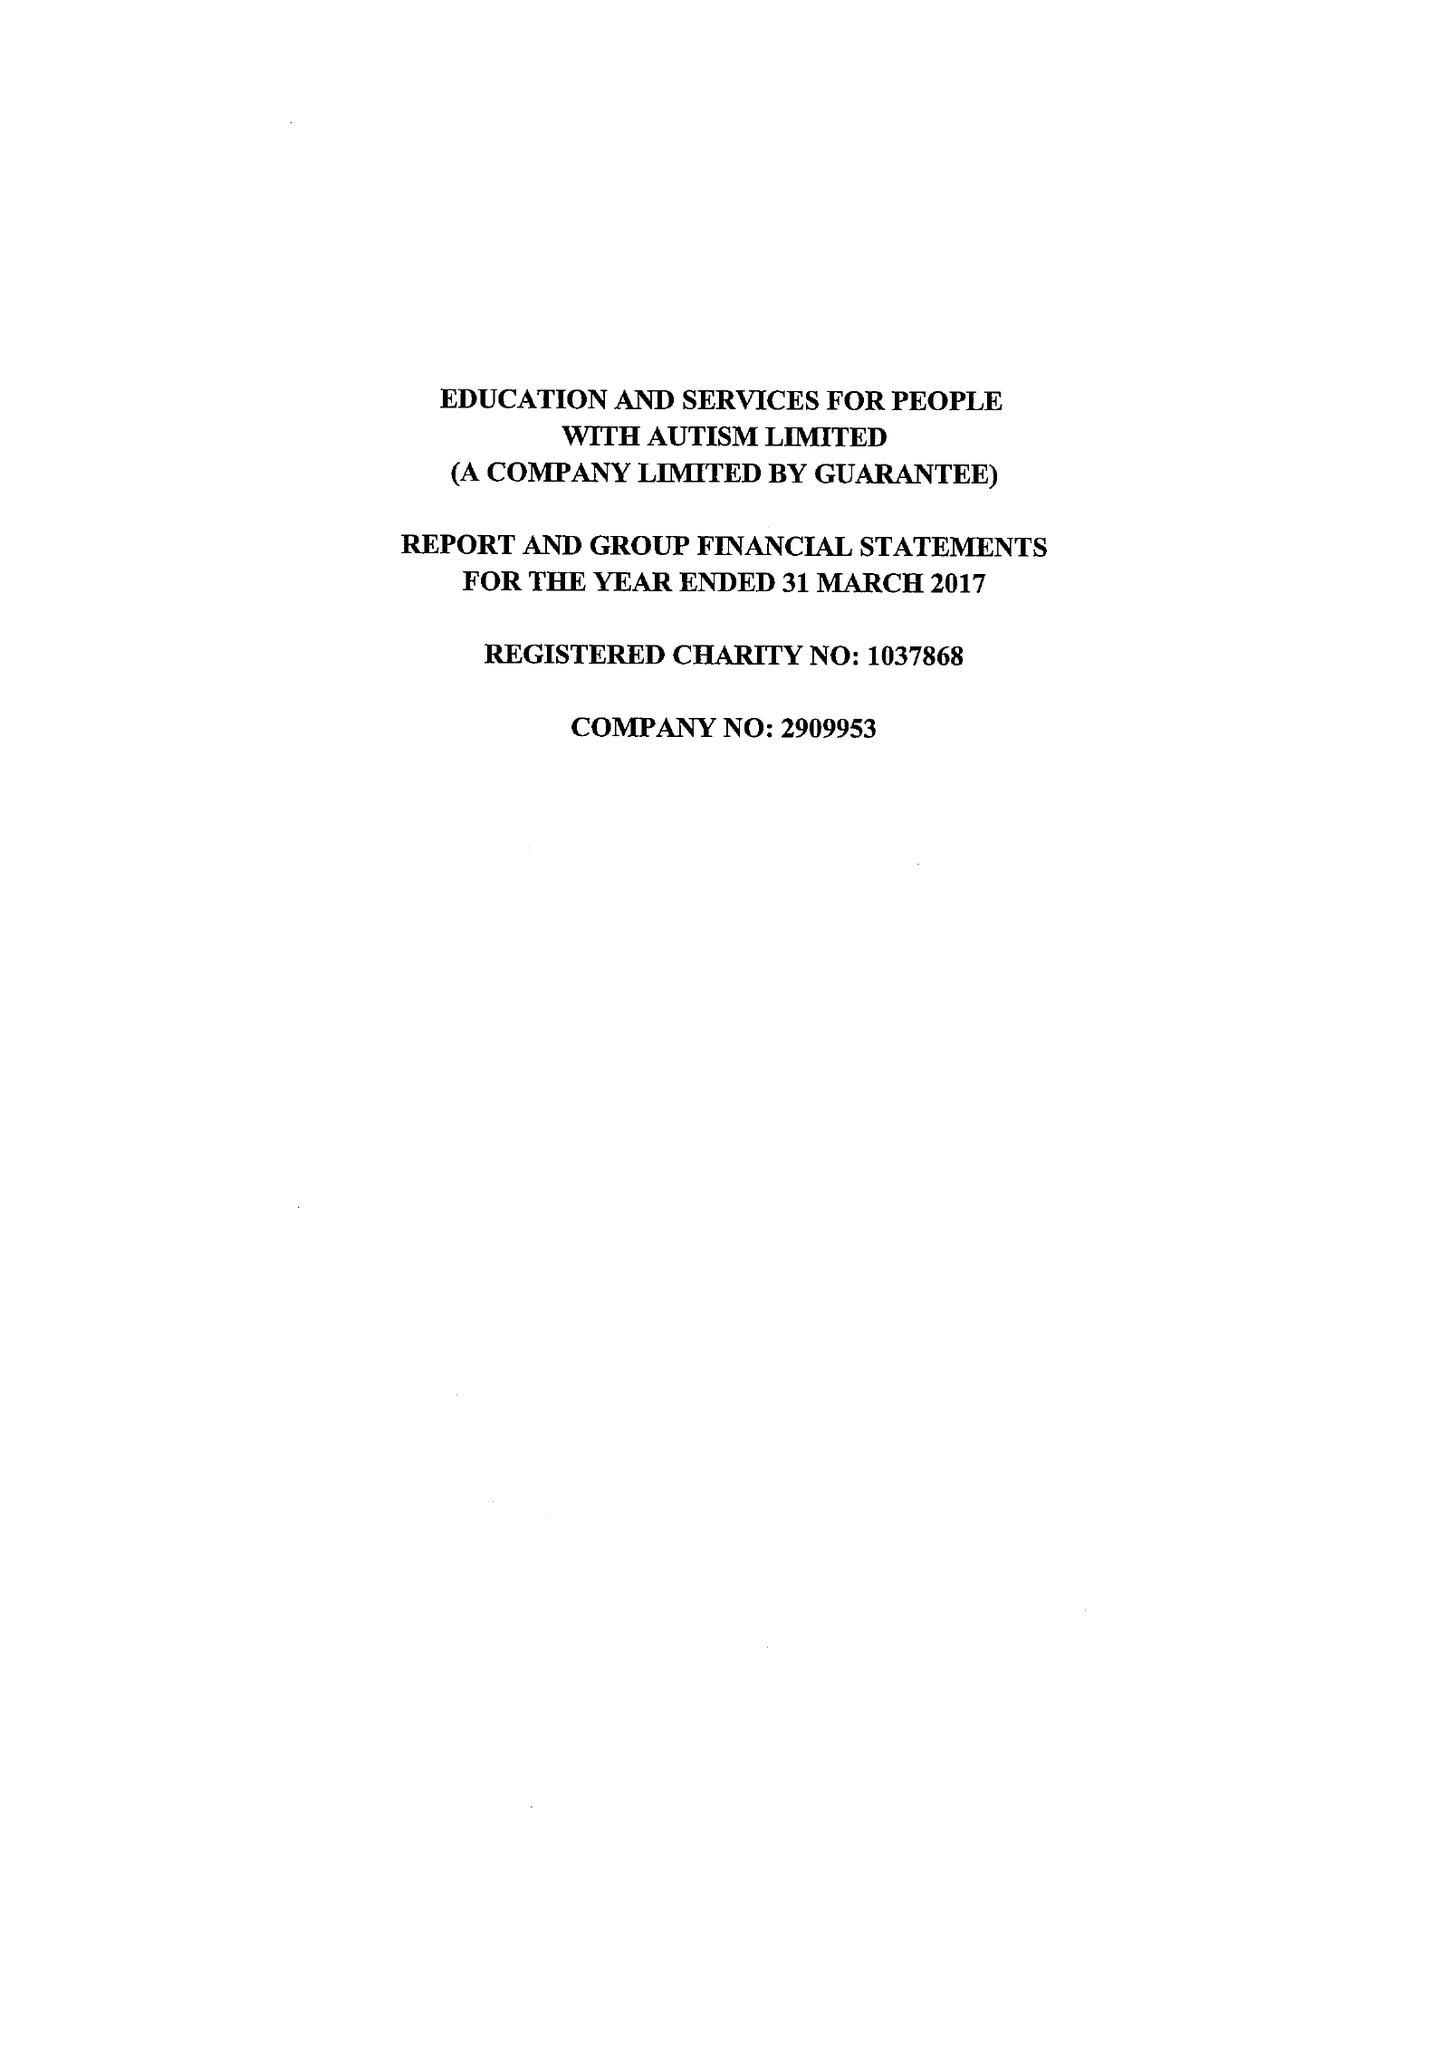What is the value for the charity_name?
Answer the question using a single word or phrase. Education and Services For People With Autism Ltd. 